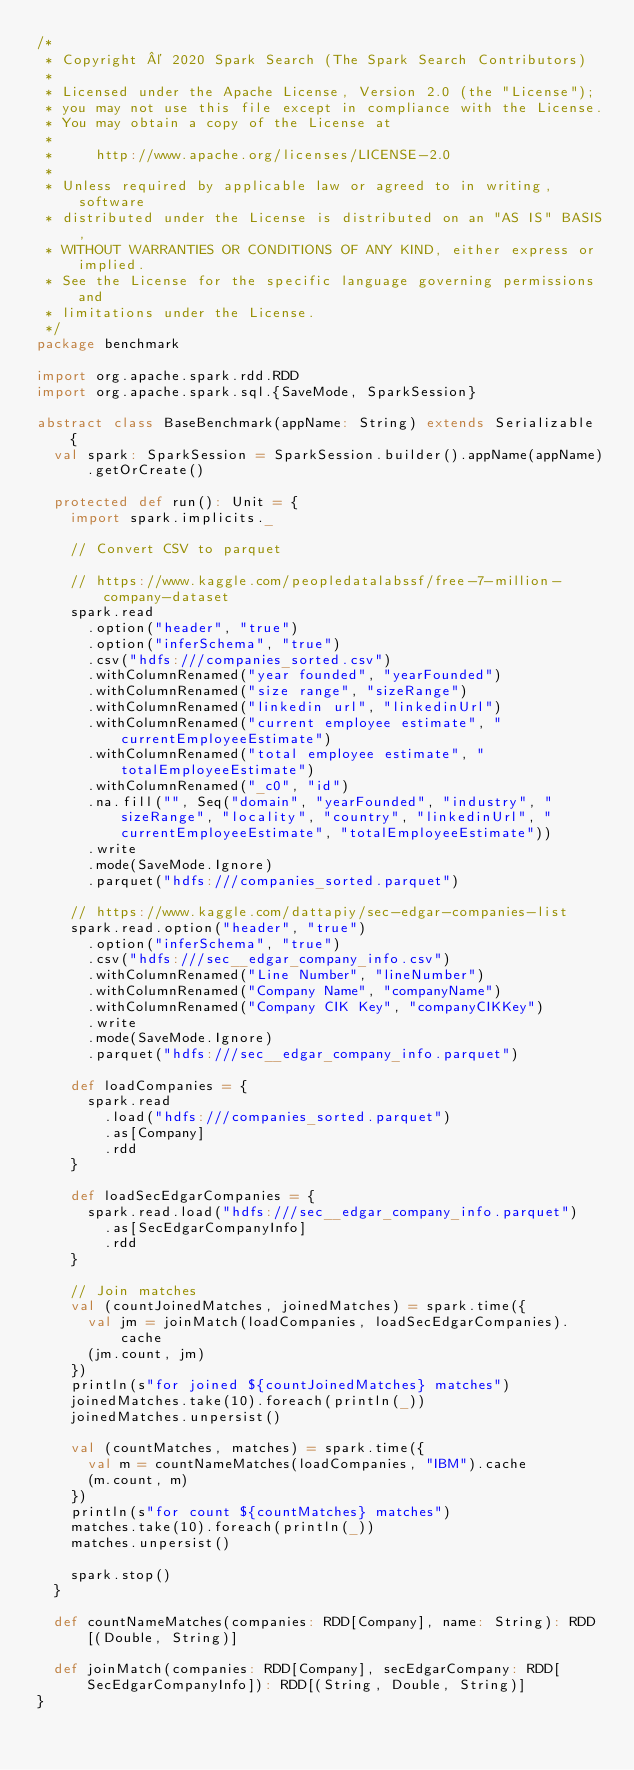<code> <loc_0><loc_0><loc_500><loc_500><_Scala_>/*
 * Copyright © 2020 Spark Search (The Spark Search Contributors)
 *
 * Licensed under the Apache License, Version 2.0 (the "License");
 * you may not use this file except in compliance with the License.
 * You may obtain a copy of the License at
 *
 *     http://www.apache.org/licenses/LICENSE-2.0
 *
 * Unless required by applicable law or agreed to in writing, software
 * distributed under the License is distributed on an "AS IS" BASIS,
 * WITHOUT WARRANTIES OR CONDITIONS OF ANY KIND, either express or implied.
 * See the License for the specific language governing permissions and
 * limitations under the License.
 */
package benchmark

import org.apache.spark.rdd.RDD
import org.apache.spark.sql.{SaveMode, SparkSession}

abstract class BaseBenchmark(appName: String) extends Serializable {
  val spark: SparkSession = SparkSession.builder().appName(appName).getOrCreate()

  protected def run(): Unit = {
    import spark.implicits._

    // Convert CSV to parquet

    // https://www.kaggle.com/peopledatalabssf/free-7-million-company-dataset
    spark.read
      .option("header", "true")
      .option("inferSchema", "true")
      .csv("hdfs:///companies_sorted.csv")
      .withColumnRenamed("year founded", "yearFounded")
      .withColumnRenamed("size range", "sizeRange")
      .withColumnRenamed("linkedin url", "linkedinUrl")
      .withColumnRenamed("current employee estimate", "currentEmployeeEstimate")
      .withColumnRenamed("total employee estimate", "totalEmployeeEstimate")
      .withColumnRenamed("_c0", "id")
      .na.fill("", Seq("domain", "yearFounded", "industry", "sizeRange", "locality", "country", "linkedinUrl", "currentEmployeeEstimate", "totalEmployeeEstimate"))
      .write
      .mode(SaveMode.Ignore)
      .parquet("hdfs:///companies_sorted.parquet")

    // https://www.kaggle.com/dattapiy/sec-edgar-companies-list
    spark.read.option("header", "true")
      .option("inferSchema", "true")
      .csv("hdfs:///sec__edgar_company_info.csv")
      .withColumnRenamed("Line Number", "lineNumber")
      .withColumnRenamed("Company Name", "companyName")
      .withColumnRenamed("Company CIK Key", "companyCIKKey")
      .write
      .mode(SaveMode.Ignore)
      .parquet("hdfs:///sec__edgar_company_info.parquet")

    def loadCompanies = {
      spark.read
        .load("hdfs:///companies_sorted.parquet")
        .as[Company]
        .rdd
    }

    def loadSecEdgarCompanies = {
      spark.read.load("hdfs:///sec__edgar_company_info.parquet")
        .as[SecEdgarCompanyInfo]
        .rdd
    }

    // Join matches
    val (countJoinedMatches, joinedMatches) = spark.time({
      val jm = joinMatch(loadCompanies, loadSecEdgarCompanies).cache
      (jm.count, jm)
    })
    println(s"for joined ${countJoinedMatches} matches")
    joinedMatches.take(10).foreach(println(_))
    joinedMatches.unpersist()

    val (countMatches, matches) = spark.time({
      val m = countNameMatches(loadCompanies, "IBM").cache
      (m.count, m)
    })
    println(s"for count ${countMatches} matches")
    matches.take(10).foreach(println(_))
    matches.unpersist()

    spark.stop()
  }

  def countNameMatches(companies: RDD[Company], name: String): RDD[(Double, String)]

  def joinMatch(companies: RDD[Company], secEdgarCompany: RDD[SecEdgarCompanyInfo]): RDD[(String, Double, String)]
}
</code> 